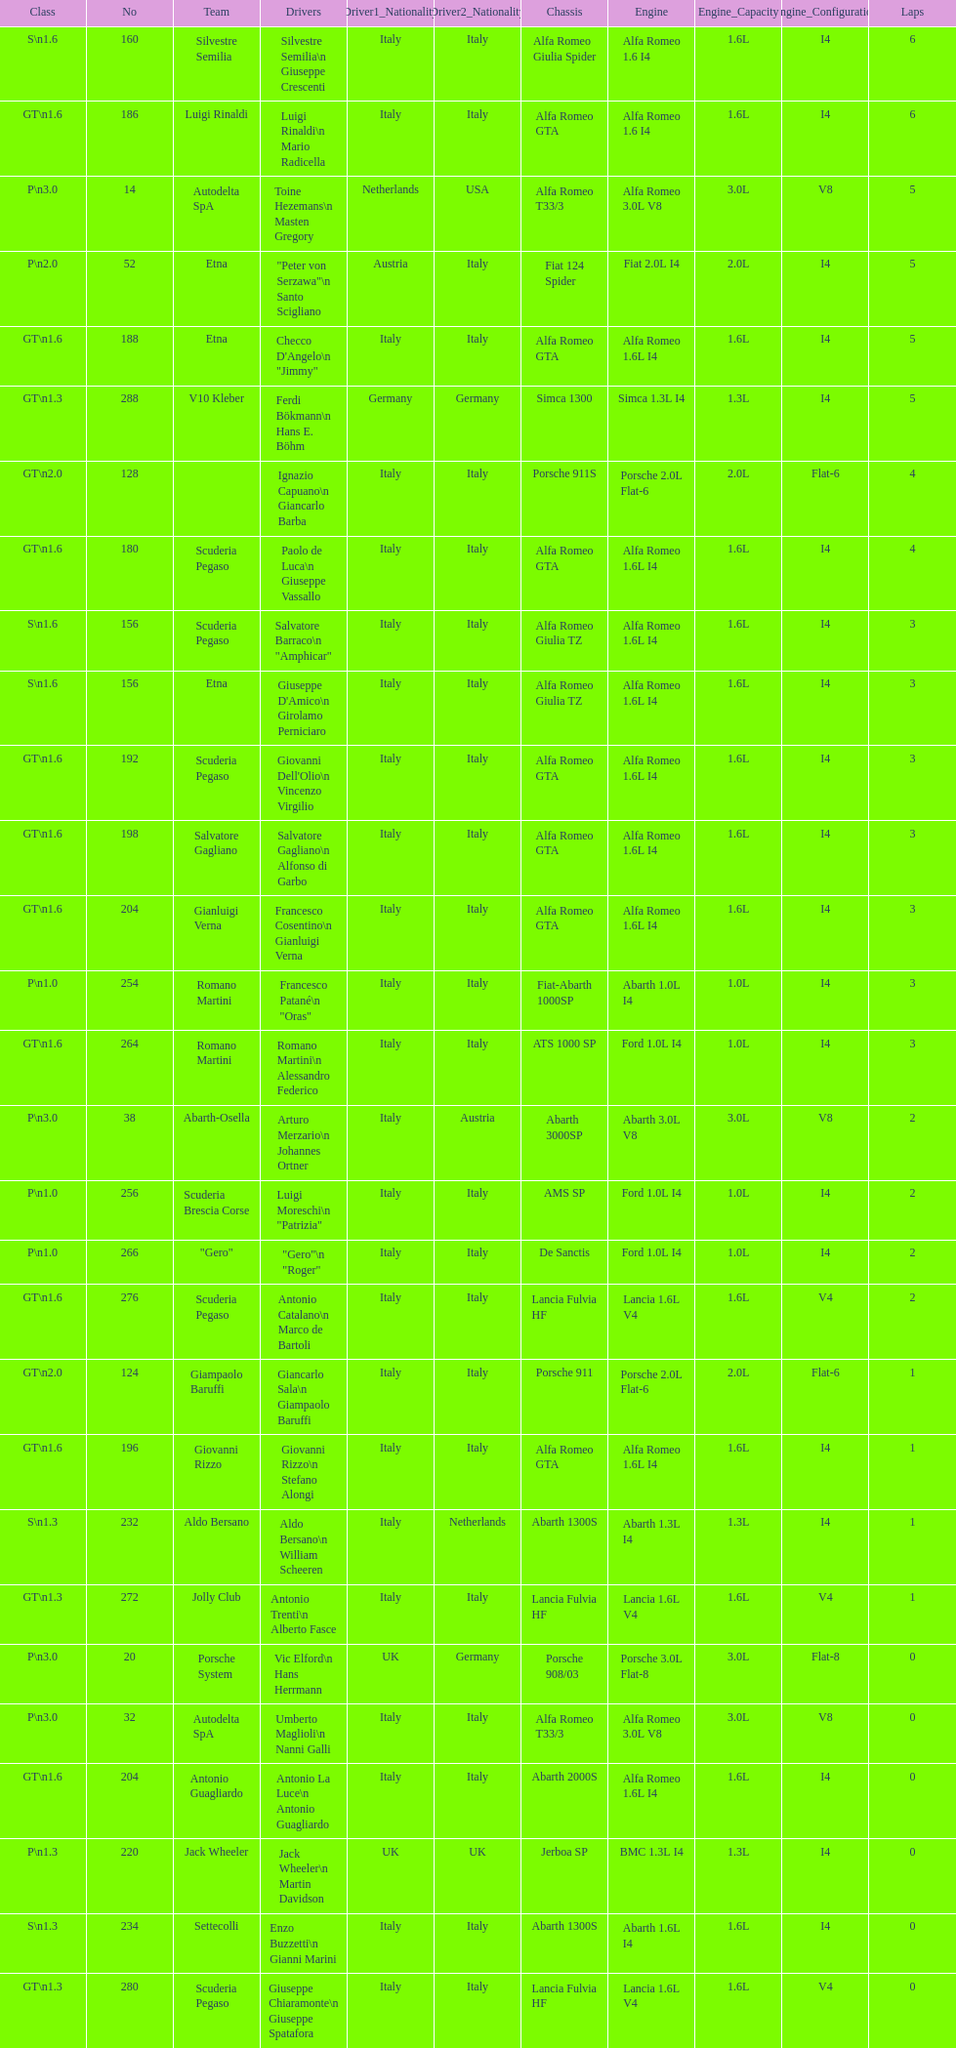Which chassis is in the middle of simca 1300 and alfa romeo gta? Porsche 911S. 